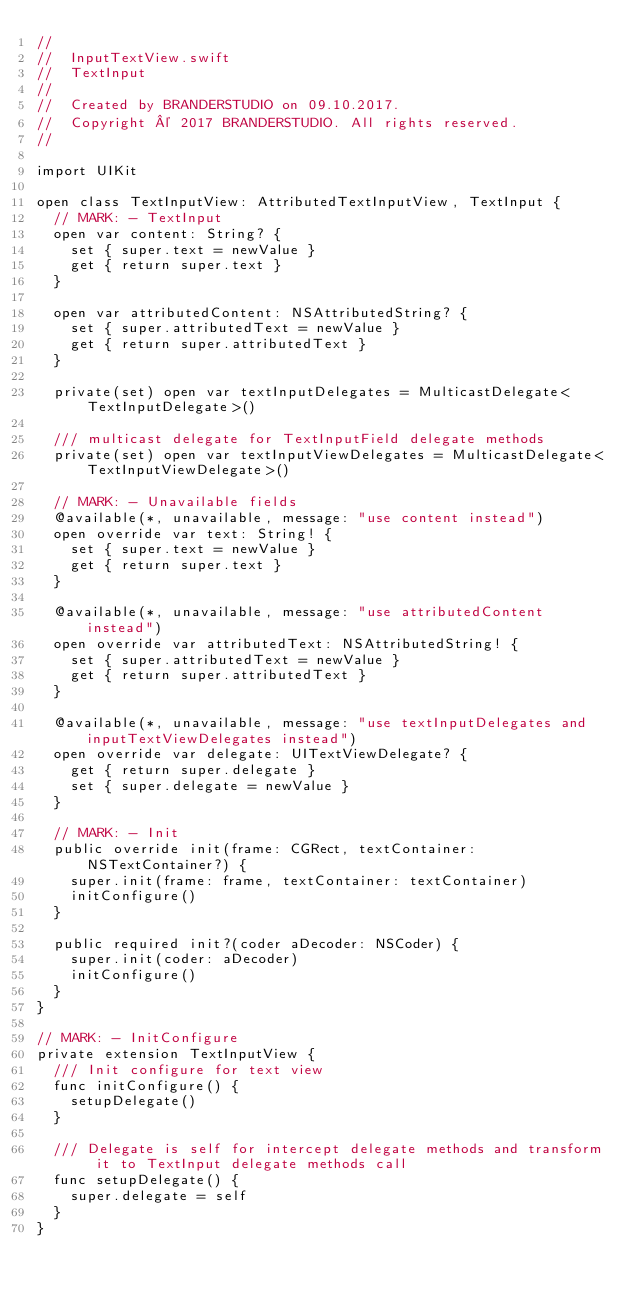<code> <loc_0><loc_0><loc_500><loc_500><_Swift_>//
//  InputTextView.swift
//  TextInput
//
//  Created by BRANDERSTUDIO on 09.10.2017.
//  Copyright © 2017 BRANDERSTUDIO. All rights reserved.
//

import UIKit

open class TextInputView: AttributedTextInputView, TextInput {
  // MARK: - TextInput
  open var content: String? {
    set { super.text = newValue }
    get { return super.text }
  }
  
  open var attributedContent: NSAttributedString? {
    set { super.attributedText = newValue }
    get { return super.attributedText }
  }
  
  private(set) open var textInputDelegates = MulticastDelegate<TextInputDelegate>()
  
  /// multicast delegate for TextInputField delegate methods
  private(set) open var textInputViewDelegates = MulticastDelegate<TextInputViewDelegate>()
  
  // MARK: - Unavailable fields
  @available(*, unavailable, message: "use content instead")
  open override var text: String! {
    set { super.text = newValue }
    get { return super.text }
  }
  
  @available(*, unavailable, message: "use attributedContent instead")
  open override var attributedText: NSAttributedString! {
    set { super.attributedText = newValue }
    get { return super.attributedText }
  }
  
  @available(*, unavailable, message: "use textInputDelegates and inputTextViewDelegates instead")
  open override var delegate: UITextViewDelegate? {
    get { return super.delegate }
    set { super.delegate = newValue }
  }
  
  // MARK: - Init
  public override init(frame: CGRect, textContainer: NSTextContainer?) {
    super.init(frame: frame, textContainer: textContainer)
    initConfigure()
  }
  
  public required init?(coder aDecoder: NSCoder) {
    super.init(coder: aDecoder)
    initConfigure()
  }
}

// MARK: - InitConfigure
private extension TextInputView {
  /// Init configure for text view
  func initConfigure() {
    setupDelegate()
  }
  
  /// Delegate is self for intercept delegate methods and transform it to TextInput delegate methods call
  func setupDelegate() {
    super.delegate = self
  }
}
</code> 